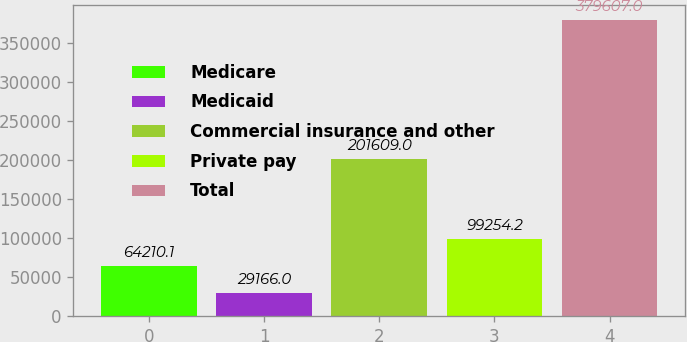Convert chart to OTSL. <chart><loc_0><loc_0><loc_500><loc_500><bar_chart><fcel>Medicare<fcel>Medicaid<fcel>Commercial insurance and other<fcel>Private pay<fcel>Total<nl><fcel>64210.1<fcel>29166<fcel>201609<fcel>99254.2<fcel>379607<nl></chart> 